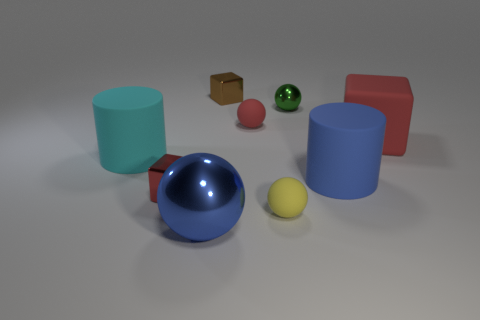Subtract all balls. How many objects are left? 5 Add 3 yellow objects. How many yellow objects exist? 4 Subtract 0 brown cylinders. How many objects are left? 9 Subtract all tiny yellow matte objects. Subtract all small shiny spheres. How many objects are left? 7 Add 6 cyan things. How many cyan things are left? 7 